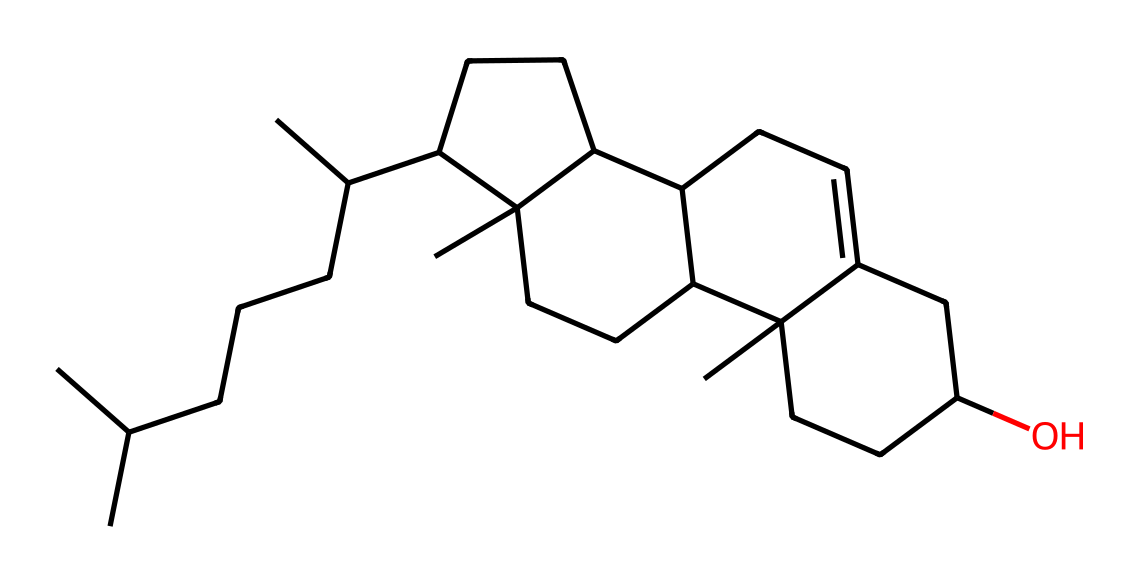What is the molecular formula of lanolin? By analyzing the SMILES representation, we can count the carbon (C) and hydrogen (H) atoms present. The structure indicates a total of 27 carbon atoms and 48 hydrogen atoms. Therefore, the molecular formula can be derived as C27H48.
Answer: C27H48 How many rings are present in the chemical structure of lanolin? The provided SMILES notation includes positions indicating cyclic structures. Upon visualizing, we can identify two fused rings and observe that there are four distinct cyclic parts in the entire molecule.
Answer: four Does lanolin contain any functional groups other than hydrocarbons? Looking at the visual structure and the SMILES representation, there is a hydroxyl (-OH) group present in the molecule, which is common in alcohols. Hence, it does contain a functional group.
Answer: yes What is the primary use of lanolin based on its chemical structure? The structure presents a complex composition that includes hydrophobic and hydrophilic characteristics, making it a natural emulsifier and moisturizer typically used in skincare products.
Answer: skincare What type of molecular interactions would lanolin engage in with skin? The hydroxyl group can form hydrogen bonds with water, and the long hydrocarbon chains allow for van der Waals interactions with skin lipids, signifying strong hydrophilic and hydrophobic interactions.
Answer: hydrogen bonds, van der Waals Is lanolin derived from a renewable source? Lanolin is a natural product obtained from sheep's wool, making it inherently renewable as it can be sourced sustainably from sheep that are shorn annually.
Answer: renewable 